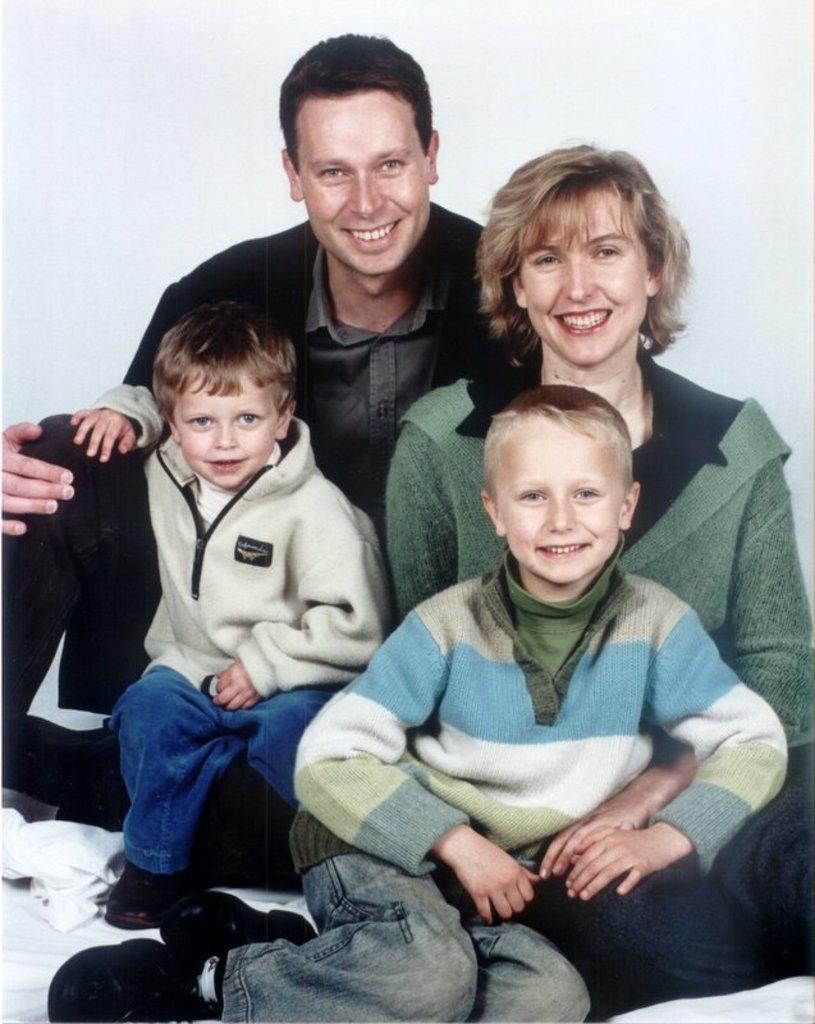In one or two sentences, can you explain what this image depicts? In this picture I can see 2 boys, a man and a woman in front and I see that they're sitting. I can also see that all of them are smiling. I see that it is white color in the background. 